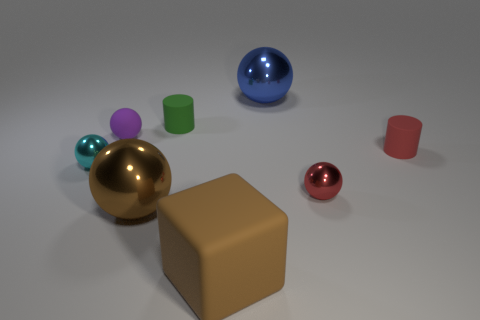Add 1 green matte things. How many objects exist? 9 Subtract all red metal spheres. How many spheres are left? 4 Subtract all green cylinders. How many cylinders are left? 1 Subtract 4 spheres. How many spheres are left? 1 Subtract all blocks. How many objects are left? 7 Subtract all green cylinders. Subtract all brown spheres. How many cylinders are left? 1 Subtract all red spheres. How many red cylinders are left? 1 Subtract all tiny metal objects. Subtract all tiny cylinders. How many objects are left? 4 Add 2 blocks. How many blocks are left? 3 Add 1 tiny purple rubber cylinders. How many tiny purple rubber cylinders exist? 1 